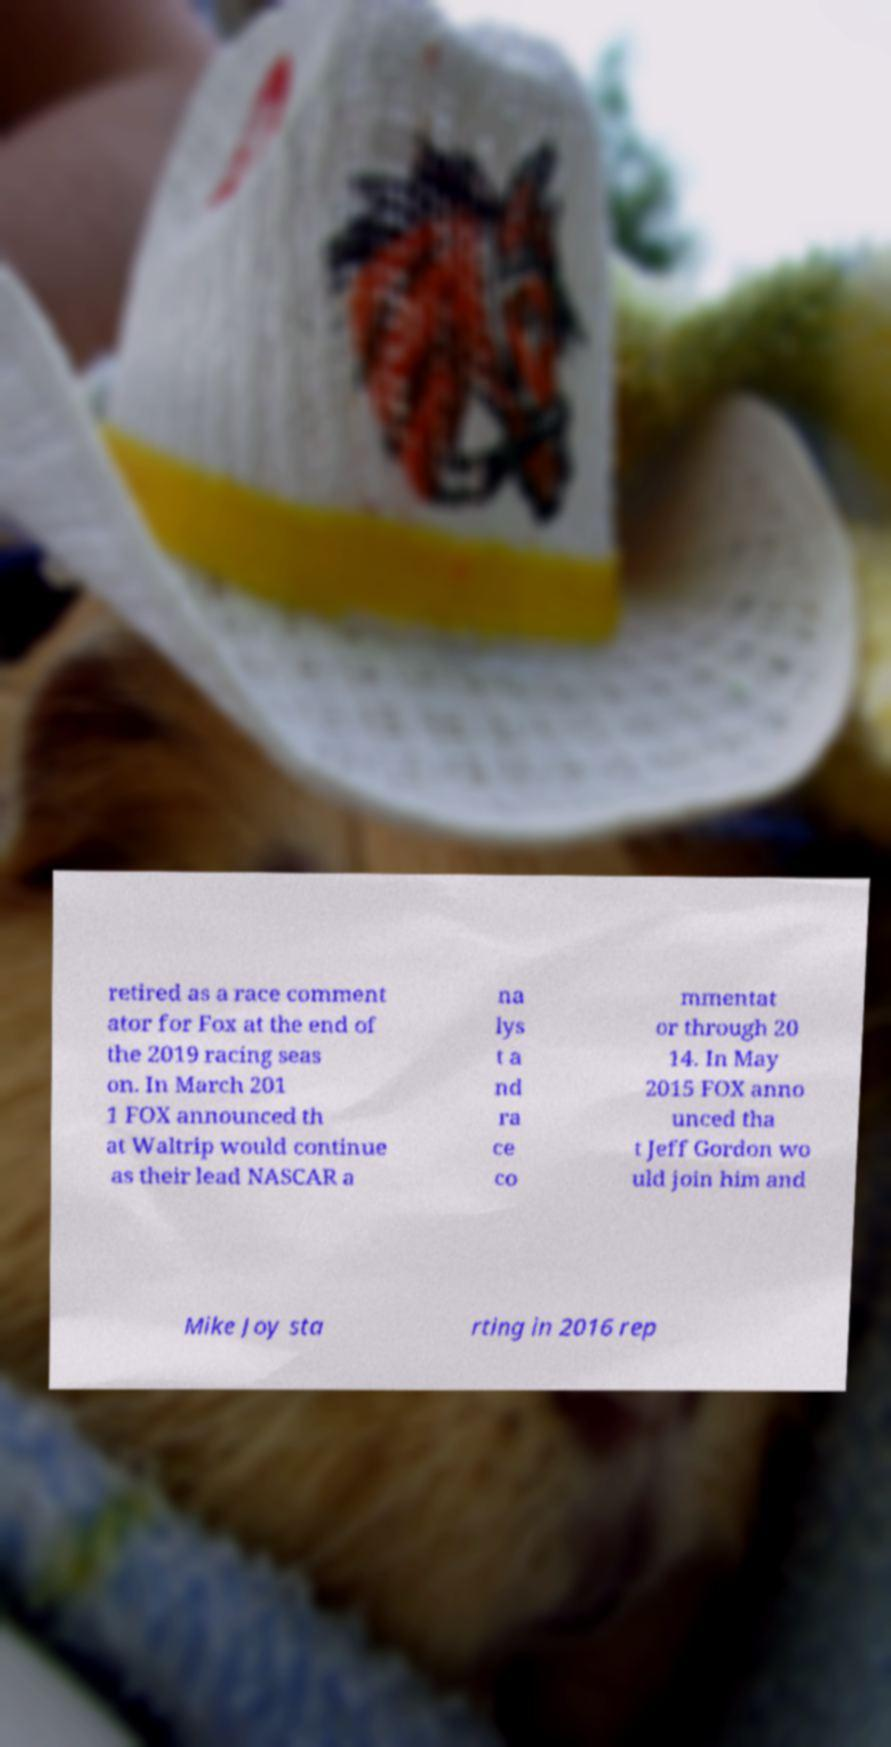Please read and relay the text visible in this image. What does it say? retired as a race comment ator for Fox at the end of the 2019 racing seas on. In March 201 1 FOX announced th at Waltrip would continue as their lead NASCAR a na lys t a nd ra ce co mmentat or through 20 14. In May 2015 FOX anno unced tha t Jeff Gordon wo uld join him and Mike Joy sta rting in 2016 rep 